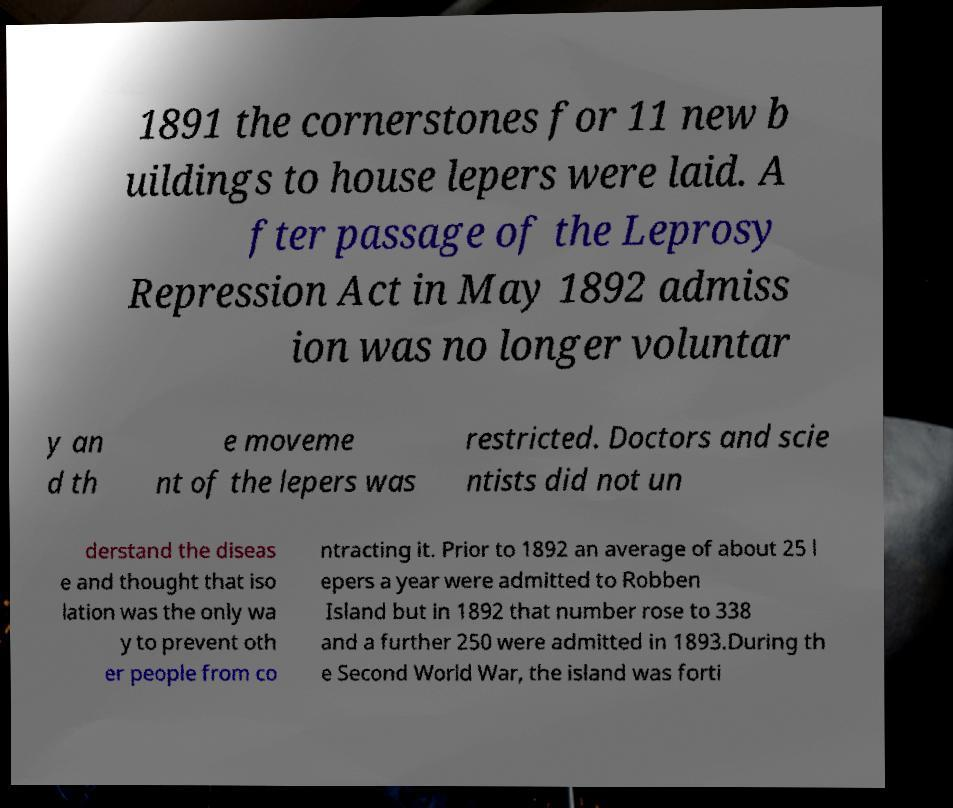Please read and relay the text visible in this image. What does it say? 1891 the cornerstones for 11 new b uildings to house lepers were laid. A fter passage of the Leprosy Repression Act in May 1892 admiss ion was no longer voluntar y an d th e moveme nt of the lepers was restricted. Doctors and scie ntists did not un derstand the diseas e and thought that iso lation was the only wa y to prevent oth er people from co ntracting it. Prior to 1892 an average of about 25 l epers a year were admitted to Robben Island but in 1892 that number rose to 338 and a further 250 were admitted in 1893.During th e Second World War, the island was forti 